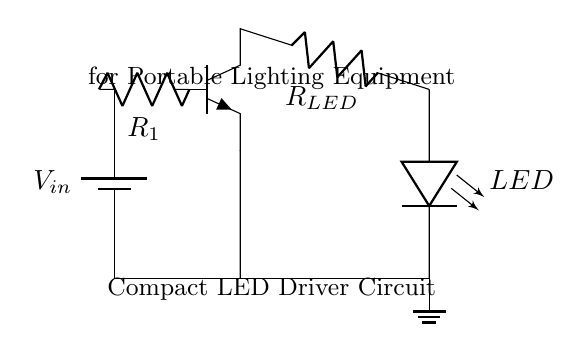What is the power source in this circuit? The power source in this circuit is a battery, indicated by the symbol at the top left of the diagram. It is labeled as V-in, which denotes the input voltage from the battery.
Answer: battery What component controls the LED brightness? The component that controls the LED brightness is the resistor labeled R-LED. This resistor limits the current flowing through the LED, affecting its brightness.
Answer: R-LED How many resistors are present in the circuit? There are two resistors present in the circuit. One is R-1 connected to the transistor base, and the other is R-LED connected in series with the LED.
Answer: two What type of transistor is used in this circuit? The circuit uses an NPN transistor, as indicated by the symbol shown in the diagram. This type of transistor is commonly used to amplify or switch electronic signals.
Answer: NPN What does the ground symbol indicate in the circuit? The ground symbol signifies a reference point in the circuit, typically the zero voltage level. This ensures that all voltages in the circuit are measured relative to this point.
Answer: reference point What is the primary purpose of this circuit? The primary purpose of this circuit is to drive an LED, providing illumination in portable lighting equipment. The components work together to enable a safe and efficient operation of the LED.
Answer: drive an LED Why is a resistor connected to the base of the transistor? A resistor is connected to the base of the transistor to limit the base current. This is essential to ensure that the transistor operates within its safe limits and avoids damage while controlling the LED.
Answer: to limit base current 